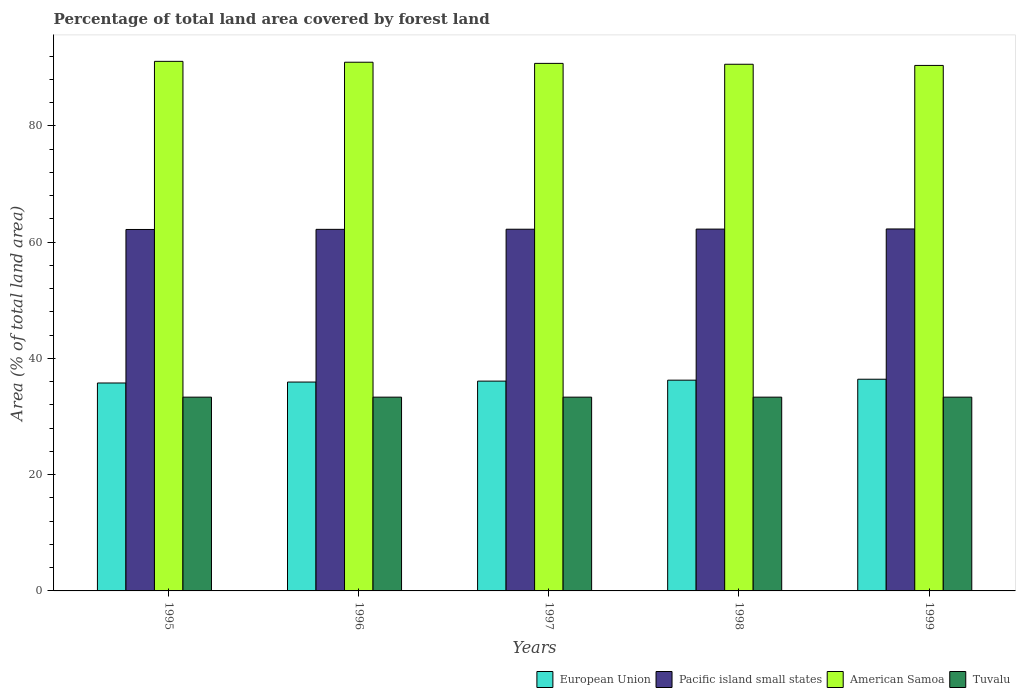How many different coloured bars are there?
Give a very brief answer. 4. How many groups of bars are there?
Make the answer very short. 5. Are the number of bars on each tick of the X-axis equal?
Offer a very short reply. Yes. How many bars are there on the 5th tick from the left?
Offer a very short reply. 4. In how many cases, is the number of bars for a given year not equal to the number of legend labels?
Your answer should be compact. 0. What is the percentage of forest land in Pacific island small states in 1999?
Make the answer very short. 62.27. Across all years, what is the maximum percentage of forest land in Tuvalu?
Offer a terse response. 33.33. Across all years, what is the minimum percentage of forest land in Tuvalu?
Ensure brevity in your answer.  33.33. In which year was the percentage of forest land in European Union maximum?
Offer a terse response. 1999. In which year was the percentage of forest land in Pacific island small states minimum?
Make the answer very short. 1995. What is the total percentage of forest land in Pacific island small states in the graph?
Offer a terse response. 311.11. What is the difference between the percentage of forest land in European Union in 1996 and that in 1999?
Keep it short and to the point. -0.49. What is the difference between the percentage of forest land in Pacific island small states in 1996 and the percentage of forest land in European Union in 1995?
Offer a very short reply. 26.43. What is the average percentage of forest land in American Samoa per year?
Provide a short and direct response. 90.76. In the year 1999, what is the difference between the percentage of forest land in American Samoa and percentage of forest land in Pacific island small states?
Give a very brief answer. 28.13. In how many years, is the percentage of forest land in European Union greater than 84 %?
Provide a succinct answer. 0. What is the ratio of the percentage of forest land in American Samoa in 1996 to that in 1999?
Keep it short and to the point. 1.01. Is the percentage of forest land in American Samoa in 1995 less than that in 1999?
Your answer should be very brief. No. What is the difference between the highest and the second highest percentage of forest land in Pacific island small states?
Provide a succinct answer. 0.02. What is the difference between the highest and the lowest percentage of forest land in European Union?
Offer a very short reply. 0.65. In how many years, is the percentage of forest land in European Union greater than the average percentage of forest land in European Union taken over all years?
Make the answer very short. 2. Is the sum of the percentage of forest land in Tuvalu in 1995 and 1999 greater than the maximum percentage of forest land in European Union across all years?
Make the answer very short. Yes. What does the 2nd bar from the left in 1997 represents?
Your response must be concise. Pacific island small states. What does the 3rd bar from the right in 1996 represents?
Your answer should be very brief. Pacific island small states. How many years are there in the graph?
Provide a succinct answer. 5. What is the difference between two consecutive major ticks on the Y-axis?
Your answer should be compact. 20. Are the values on the major ticks of Y-axis written in scientific E-notation?
Offer a terse response. No. Does the graph contain grids?
Your answer should be compact. No. Where does the legend appear in the graph?
Give a very brief answer. Bottom right. How are the legend labels stacked?
Keep it short and to the point. Horizontal. What is the title of the graph?
Give a very brief answer. Percentage of total land area covered by forest land. Does "United Kingdom" appear as one of the legend labels in the graph?
Offer a very short reply. No. What is the label or title of the Y-axis?
Your response must be concise. Area (% of total land area). What is the Area (% of total land area) in European Union in 1995?
Your response must be concise. 35.77. What is the Area (% of total land area) of Pacific island small states in 1995?
Your answer should be very brief. 62.18. What is the Area (% of total land area) in American Samoa in 1995?
Offer a very short reply. 91.1. What is the Area (% of total land area) of Tuvalu in 1995?
Offer a terse response. 33.33. What is the Area (% of total land area) in European Union in 1996?
Keep it short and to the point. 35.93. What is the Area (% of total land area) of Pacific island small states in 1996?
Make the answer very short. 62.2. What is the Area (% of total land area) in American Samoa in 1996?
Provide a short and direct response. 90.95. What is the Area (% of total land area) in Tuvalu in 1996?
Your answer should be compact. 33.33. What is the Area (% of total land area) in European Union in 1997?
Ensure brevity in your answer.  36.09. What is the Area (% of total land area) of Pacific island small states in 1997?
Your answer should be very brief. 62.22. What is the Area (% of total land area) in American Samoa in 1997?
Make the answer very short. 90.75. What is the Area (% of total land area) in Tuvalu in 1997?
Ensure brevity in your answer.  33.33. What is the Area (% of total land area) of European Union in 1998?
Your response must be concise. 36.26. What is the Area (% of total land area) of Pacific island small states in 1998?
Offer a terse response. 62.24. What is the Area (% of total land area) in American Samoa in 1998?
Give a very brief answer. 90.6. What is the Area (% of total land area) of Tuvalu in 1998?
Provide a short and direct response. 33.33. What is the Area (% of total land area) in European Union in 1999?
Ensure brevity in your answer.  36.42. What is the Area (% of total land area) of Pacific island small states in 1999?
Keep it short and to the point. 62.27. What is the Area (% of total land area) of American Samoa in 1999?
Your response must be concise. 90.4. What is the Area (% of total land area) in Tuvalu in 1999?
Give a very brief answer. 33.33. Across all years, what is the maximum Area (% of total land area) of European Union?
Offer a very short reply. 36.42. Across all years, what is the maximum Area (% of total land area) of Pacific island small states?
Keep it short and to the point. 62.27. Across all years, what is the maximum Area (% of total land area) of American Samoa?
Ensure brevity in your answer.  91.1. Across all years, what is the maximum Area (% of total land area) of Tuvalu?
Your answer should be very brief. 33.33. Across all years, what is the minimum Area (% of total land area) of European Union?
Your answer should be very brief. 35.77. Across all years, what is the minimum Area (% of total land area) in Pacific island small states?
Your response must be concise. 62.18. Across all years, what is the minimum Area (% of total land area) of American Samoa?
Make the answer very short. 90.4. Across all years, what is the minimum Area (% of total land area) in Tuvalu?
Your answer should be very brief. 33.33. What is the total Area (% of total land area) in European Union in the graph?
Provide a short and direct response. 180.46. What is the total Area (% of total land area) of Pacific island small states in the graph?
Make the answer very short. 311.11. What is the total Area (% of total land area) of American Samoa in the graph?
Provide a short and direct response. 453.8. What is the total Area (% of total land area) in Tuvalu in the graph?
Make the answer very short. 166.67. What is the difference between the Area (% of total land area) of European Union in 1995 and that in 1996?
Your answer should be very brief. -0.16. What is the difference between the Area (% of total land area) in Pacific island small states in 1995 and that in 1996?
Give a very brief answer. -0.02. What is the difference between the Area (% of total land area) in American Samoa in 1995 and that in 1996?
Make the answer very short. 0.15. What is the difference between the Area (% of total land area) in Tuvalu in 1995 and that in 1996?
Provide a succinct answer. 0. What is the difference between the Area (% of total land area) in European Union in 1995 and that in 1997?
Your answer should be compact. -0.32. What is the difference between the Area (% of total land area) of Pacific island small states in 1995 and that in 1997?
Offer a terse response. -0.04. What is the difference between the Area (% of total land area) of American Samoa in 1995 and that in 1997?
Give a very brief answer. 0.35. What is the difference between the Area (% of total land area) in Tuvalu in 1995 and that in 1997?
Offer a very short reply. 0. What is the difference between the Area (% of total land area) of European Union in 1995 and that in 1998?
Give a very brief answer. -0.49. What is the difference between the Area (% of total land area) in Pacific island small states in 1995 and that in 1998?
Provide a succinct answer. -0.07. What is the difference between the Area (% of total land area) of Tuvalu in 1995 and that in 1998?
Give a very brief answer. 0. What is the difference between the Area (% of total land area) in European Union in 1995 and that in 1999?
Your answer should be compact. -0.65. What is the difference between the Area (% of total land area) in Pacific island small states in 1995 and that in 1999?
Ensure brevity in your answer.  -0.09. What is the difference between the Area (% of total land area) in Tuvalu in 1995 and that in 1999?
Offer a terse response. 0. What is the difference between the Area (% of total land area) in European Union in 1996 and that in 1997?
Ensure brevity in your answer.  -0.16. What is the difference between the Area (% of total land area) of Pacific island small states in 1996 and that in 1997?
Offer a very short reply. -0.02. What is the difference between the Area (% of total land area) of American Samoa in 1996 and that in 1997?
Keep it short and to the point. 0.2. What is the difference between the Area (% of total land area) in Tuvalu in 1996 and that in 1997?
Your answer should be compact. 0. What is the difference between the Area (% of total land area) of European Union in 1996 and that in 1998?
Provide a succinct answer. -0.32. What is the difference between the Area (% of total land area) of Pacific island small states in 1996 and that in 1998?
Make the answer very short. -0.04. What is the difference between the Area (% of total land area) in Tuvalu in 1996 and that in 1998?
Make the answer very short. 0. What is the difference between the Area (% of total land area) of European Union in 1996 and that in 1999?
Your answer should be compact. -0.49. What is the difference between the Area (% of total land area) in Pacific island small states in 1996 and that in 1999?
Provide a succinct answer. -0.07. What is the difference between the Area (% of total land area) of American Samoa in 1996 and that in 1999?
Your answer should be very brief. 0.55. What is the difference between the Area (% of total land area) of European Union in 1997 and that in 1998?
Offer a very short reply. -0.16. What is the difference between the Area (% of total land area) of Pacific island small states in 1997 and that in 1998?
Your answer should be very brief. -0.02. What is the difference between the Area (% of total land area) in European Union in 1997 and that in 1999?
Ensure brevity in your answer.  -0.32. What is the difference between the Area (% of total land area) in Pacific island small states in 1997 and that in 1999?
Offer a terse response. -0.04. What is the difference between the Area (% of total land area) of European Union in 1998 and that in 1999?
Give a very brief answer. -0.16. What is the difference between the Area (% of total land area) in Pacific island small states in 1998 and that in 1999?
Your response must be concise. -0.02. What is the difference between the Area (% of total land area) in Tuvalu in 1998 and that in 1999?
Provide a succinct answer. 0. What is the difference between the Area (% of total land area) in European Union in 1995 and the Area (% of total land area) in Pacific island small states in 1996?
Offer a very short reply. -26.43. What is the difference between the Area (% of total land area) of European Union in 1995 and the Area (% of total land area) of American Samoa in 1996?
Your answer should be compact. -55.18. What is the difference between the Area (% of total land area) in European Union in 1995 and the Area (% of total land area) in Tuvalu in 1996?
Ensure brevity in your answer.  2.44. What is the difference between the Area (% of total land area) of Pacific island small states in 1995 and the Area (% of total land area) of American Samoa in 1996?
Give a very brief answer. -28.77. What is the difference between the Area (% of total land area) of Pacific island small states in 1995 and the Area (% of total land area) of Tuvalu in 1996?
Provide a succinct answer. 28.84. What is the difference between the Area (% of total land area) in American Samoa in 1995 and the Area (% of total land area) in Tuvalu in 1996?
Give a very brief answer. 57.77. What is the difference between the Area (% of total land area) in European Union in 1995 and the Area (% of total land area) in Pacific island small states in 1997?
Make the answer very short. -26.45. What is the difference between the Area (% of total land area) of European Union in 1995 and the Area (% of total land area) of American Samoa in 1997?
Your response must be concise. -54.98. What is the difference between the Area (% of total land area) of European Union in 1995 and the Area (% of total land area) of Tuvalu in 1997?
Your response must be concise. 2.44. What is the difference between the Area (% of total land area) in Pacific island small states in 1995 and the Area (% of total land area) in American Samoa in 1997?
Offer a very short reply. -28.57. What is the difference between the Area (% of total land area) in Pacific island small states in 1995 and the Area (% of total land area) in Tuvalu in 1997?
Your answer should be compact. 28.84. What is the difference between the Area (% of total land area) in American Samoa in 1995 and the Area (% of total land area) in Tuvalu in 1997?
Ensure brevity in your answer.  57.77. What is the difference between the Area (% of total land area) in European Union in 1995 and the Area (% of total land area) in Pacific island small states in 1998?
Offer a very short reply. -26.47. What is the difference between the Area (% of total land area) of European Union in 1995 and the Area (% of total land area) of American Samoa in 1998?
Your answer should be very brief. -54.83. What is the difference between the Area (% of total land area) of European Union in 1995 and the Area (% of total land area) of Tuvalu in 1998?
Your response must be concise. 2.44. What is the difference between the Area (% of total land area) in Pacific island small states in 1995 and the Area (% of total land area) in American Samoa in 1998?
Your response must be concise. -28.42. What is the difference between the Area (% of total land area) in Pacific island small states in 1995 and the Area (% of total land area) in Tuvalu in 1998?
Provide a succinct answer. 28.84. What is the difference between the Area (% of total land area) in American Samoa in 1995 and the Area (% of total land area) in Tuvalu in 1998?
Provide a short and direct response. 57.77. What is the difference between the Area (% of total land area) of European Union in 1995 and the Area (% of total land area) of Pacific island small states in 1999?
Make the answer very short. -26.5. What is the difference between the Area (% of total land area) in European Union in 1995 and the Area (% of total land area) in American Samoa in 1999?
Provide a succinct answer. -54.63. What is the difference between the Area (% of total land area) in European Union in 1995 and the Area (% of total land area) in Tuvalu in 1999?
Provide a succinct answer. 2.44. What is the difference between the Area (% of total land area) of Pacific island small states in 1995 and the Area (% of total land area) of American Samoa in 1999?
Make the answer very short. -28.22. What is the difference between the Area (% of total land area) in Pacific island small states in 1995 and the Area (% of total land area) in Tuvalu in 1999?
Provide a short and direct response. 28.84. What is the difference between the Area (% of total land area) of American Samoa in 1995 and the Area (% of total land area) of Tuvalu in 1999?
Make the answer very short. 57.77. What is the difference between the Area (% of total land area) in European Union in 1996 and the Area (% of total land area) in Pacific island small states in 1997?
Ensure brevity in your answer.  -26.29. What is the difference between the Area (% of total land area) of European Union in 1996 and the Area (% of total land area) of American Samoa in 1997?
Keep it short and to the point. -54.82. What is the difference between the Area (% of total land area) in European Union in 1996 and the Area (% of total land area) in Tuvalu in 1997?
Offer a very short reply. 2.6. What is the difference between the Area (% of total land area) of Pacific island small states in 1996 and the Area (% of total land area) of American Samoa in 1997?
Your response must be concise. -28.55. What is the difference between the Area (% of total land area) in Pacific island small states in 1996 and the Area (% of total land area) in Tuvalu in 1997?
Offer a very short reply. 28.87. What is the difference between the Area (% of total land area) in American Samoa in 1996 and the Area (% of total land area) in Tuvalu in 1997?
Keep it short and to the point. 57.62. What is the difference between the Area (% of total land area) in European Union in 1996 and the Area (% of total land area) in Pacific island small states in 1998?
Ensure brevity in your answer.  -26.31. What is the difference between the Area (% of total land area) of European Union in 1996 and the Area (% of total land area) of American Samoa in 1998?
Keep it short and to the point. -54.67. What is the difference between the Area (% of total land area) in European Union in 1996 and the Area (% of total land area) in Tuvalu in 1998?
Ensure brevity in your answer.  2.6. What is the difference between the Area (% of total land area) of Pacific island small states in 1996 and the Area (% of total land area) of American Samoa in 1998?
Your response must be concise. -28.4. What is the difference between the Area (% of total land area) in Pacific island small states in 1996 and the Area (% of total land area) in Tuvalu in 1998?
Offer a terse response. 28.87. What is the difference between the Area (% of total land area) of American Samoa in 1996 and the Area (% of total land area) of Tuvalu in 1998?
Your answer should be very brief. 57.62. What is the difference between the Area (% of total land area) of European Union in 1996 and the Area (% of total land area) of Pacific island small states in 1999?
Keep it short and to the point. -26.34. What is the difference between the Area (% of total land area) of European Union in 1996 and the Area (% of total land area) of American Samoa in 1999?
Your answer should be very brief. -54.47. What is the difference between the Area (% of total land area) of European Union in 1996 and the Area (% of total land area) of Tuvalu in 1999?
Ensure brevity in your answer.  2.6. What is the difference between the Area (% of total land area) of Pacific island small states in 1996 and the Area (% of total land area) of American Samoa in 1999?
Give a very brief answer. -28.2. What is the difference between the Area (% of total land area) in Pacific island small states in 1996 and the Area (% of total land area) in Tuvalu in 1999?
Keep it short and to the point. 28.87. What is the difference between the Area (% of total land area) of American Samoa in 1996 and the Area (% of total land area) of Tuvalu in 1999?
Give a very brief answer. 57.62. What is the difference between the Area (% of total land area) in European Union in 1997 and the Area (% of total land area) in Pacific island small states in 1998?
Provide a succinct answer. -26.15. What is the difference between the Area (% of total land area) of European Union in 1997 and the Area (% of total land area) of American Samoa in 1998?
Your answer should be very brief. -54.51. What is the difference between the Area (% of total land area) of European Union in 1997 and the Area (% of total land area) of Tuvalu in 1998?
Your answer should be very brief. 2.76. What is the difference between the Area (% of total land area) in Pacific island small states in 1997 and the Area (% of total land area) in American Samoa in 1998?
Your answer should be compact. -28.38. What is the difference between the Area (% of total land area) in Pacific island small states in 1997 and the Area (% of total land area) in Tuvalu in 1998?
Your response must be concise. 28.89. What is the difference between the Area (% of total land area) of American Samoa in 1997 and the Area (% of total land area) of Tuvalu in 1998?
Make the answer very short. 57.42. What is the difference between the Area (% of total land area) of European Union in 1997 and the Area (% of total land area) of Pacific island small states in 1999?
Give a very brief answer. -26.17. What is the difference between the Area (% of total land area) of European Union in 1997 and the Area (% of total land area) of American Samoa in 1999?
Offer a terse response. -54.31. What is the difference between the Area (% of total land area) in European Union in 1997 and the Area (% of total land area) in Tuvalu in 1999?
Offer a very short reply. 2.76. What is the difference between the Area (% of total land area) in Pacific island small states in 1997 and the Area (% of total land area) in American Samoa in 1999?
Make the answer very short. -28.18. What is the difference between the Area (% of total land area) of Pacific island small states in 1997 and the Area (% of total land area) of Tuvalu in 1999?
Give a very brief answer. 28.89. What is the difference between the Area (% of total land area) in American Samoa in 1997 and the Area (% of total land area) in Tuvalu in 1999?
Your answer should be very brief. 57.42. What is the difference between the Area (% of total land area) in European Union in 1998 and the Area (% of total land area) in Pacific island small states in 1999?
Offer a terse response. -26.01. What is the difference between the Area (% of total land area) of European Union in 1998 and the Area (% of total land area) of American Samoa in 1999?
Give a very brief answer. -54.14. What is the difference between the Area (% of total land area) in European Union in 1998 and the Area (% of total land area) in Tuvalu in 1999?
Offer a terse response. 2.92. What is the difference between the Area (% of total land area) of Pacific island small states in 1998 and the Area (% of total land area) of American Samoa in 1999?
Your answer should be very brief. -28.16. What is the difference between the Area (% of total land area) in Pacific island small states in 1998 and the Area (% of total land area) in Tuvalu in 1999?
Your answer should be compact. 28.91. What is the difference between the Area (% of total land area) of American Samoa in 1998 and the Area (% of total land area) of Tuvalu in 1999?
Give a very brief answer. 57.27. What is the average Area (% of total land area) in European Union per year?
Make the answer very short. 36.09. What is the average Area (% of total land area) of Pacific island small states per year?
Offer a very short reply. 62.22. What is the average Area (% of total land area) in American Samoa per year?
Provide a short and direct response. 90.76. What is the average Area (% of total land area) of Tuvalu per year?
Provide a short and direct response. 33.33. In the year 1995, what is the difference between the Area (% of total land area) of European Union and Area (% of total land area) of Pacific island small states?
Provide a succinct answer. -26.41. In the year 1995, what is the difference between the Area (% of total land area) in European Union and Area (% of total land area) in American Samoa?
Ensure brevity in your answer.  -55.33. In the year 1995, what is the difference between the Area (% of total land area) of European Union and Area (% of total land area) of Tuvalu?
Give a very brief answer. 2.44. In the year 1995, what is the difference between the Area (% of total land area) of Pacific island small states and Area (% of total land area) of American Samoa?
Provide a short and direct response. -28.92. In the year 1995, what is the difference between the Area (% of total land area) in Pacific island small states and Area (% of total land area) in Tuvalu?
Your answer should be compact. 28.84. In the year 1995, what is the difference between the Area (% of total land area) of American Samoa and Area (% of total land area) of Tuvalu?
Provide a succinct answer. 57.77. In the year 1996, what is the difference between the Area (% of total land area) of European Union and Area (% of total land area) of Pacific island small states?
Make the answer very short. -26.27. In the year 1996, what is the difference between the Area (% of total land area) in European Union and Area (% of total land area) in American Samoa?
Keep it short and to the point. -55.02. In the year 1996, what is the difference between the Area (% of total land area) of European Union and Area (% of total land area) of Tuvalu?
Keep it short and to the point. 2.6. In the year 1996, what is the difference between the Area (% of total land area) of Pacific island small states and Area (% of total land area) of American Samoa?
Your answer should be very brief. -28.75. In the year 1996, what is the difference between the Area (% of total land area) in Pacific island small states and Area (% of total land area) in Tuvalu?
Offer a very short reply. 28.87. In the year 1996, what is the difference between the Area (% of total land area) of American Samoa and Area (% of total land area) of Tuvalu?
Give a very brief answer. 57.62. In the year 1997, what is the difference between the Area (% of total land area) in European Union and Area (% of total land area) in Pacific island small states?
Provide a short and direct response. -26.13. In the year 1997, what is the difference between the Area (% of total land area) of European Union and Area (% of total land area) of American Samoa?
Give a very brief answer. -54.66. In the year 1997, what is the difference between the Area (% of total land area) in European Union and Area (% of total land area) in Tuvalu?
Provide a short and direct response. 2.76. In the year 1997, what is the difference between the Area (% of total land area) of Pacific island small states and Area (% of total land area) of American Samoa?
Give a very brief answer. -28.53. In the year 1997, what is the difference between the Area (% of total land area) of Pacific island small states and Area (% of total land area) of Tuvalu?
Provide a short and direct response. 28.89. In the year 1997, what is the difference between the Area (% of total land area) of American Samoa and Area (% of total land area) of Tuvalu?
Your answer should be compact. 57.42. In the year 1998, what is the difference between the Area (% of total land area) of European Union and Area (% of total land area) of Pacific island small states?
Offer a terse response. -25.99. In the year 1998, what is the difference between the Area (% of total land area) of European Union and Area (% of total land area) of American Samoa?
Your answer should be compact. -54.34. In the year 1998, what is the difference between the Area (% of total land area) of European Union and Area (% of total land area) of Tuvalu?
Give a very brief answer. 2.92. In the year 1998, what is the difference between the Area (% of total land area) of Pacific island small states and Area (% of total land area) of American Samoa?
Your answer should be very brief. -28.36. In the year 1998, what is the difference between the Area (% of total land area) of Pacific island small states and Area (% of total land area) of Tuvalu?
Your answer should be very brief. 28.91. In the year 1998, what is the difference between the Area (% of total land area) in American Samoa and Area (% of total land area) in Tuvalu?
Make the answer very short. 57.27. In the year 1999, what is the difference between the Area (% of total land area) of European Union and Area (% of total land area) of Pacific island small states?
Your response must be concise. -25.85. In the year 1999, what is the difference between the Area (% of total land area) in European Union and Area (% of total land area) in American Samoa?
Offer a terse response. -53.98. In the year 1999, what is the difference between the Area (% of total land area) of European Union and Area (% of total land area) of Tuvalu?
Your answer should be very brief. 3.08. In the year 1999, what is the difference between the Area (% of total land area) of Pacific island small states and Area (% of total land area) of American Samoa?
Your answer should be compact. -28.13. In the year 1999, what is the difference between the Area (% of total land area) in Pacific island small states and Area (% of total land area) in Tuvalu?
Your response must be concise. 28.93. In the year 1999, what is the difference between the Area (% of total land area) in American Samoa and Area (% of total land area) in Tuvalu?
Make the answer very short. 57.07. What is the ratio of the Area (% of total land area) in Pacific island small states in 1995 to that in 1996?
Offer a terse response. 1. What is the ratio of the Area (% of total land area) in European Union in 1995 to that in 1997?
Ensure brevity in your answer.  0.99. What is the ratio of the Area (% of total land area) of Tuvalu in 1995 to that in 1997?
Your response must be concise. 1. What is the ratio of the Area (% of total land area) of European Union in 1995 to that in 1998?
Keep it short and to the point. 0.99. What is the ratio of the Area (% of total land area) in Pacific island small states in 1995 to that in 1998?
Provide a short and direct response. 1. What is the ratio of the Area (% of total land area) of European Union in 1995 to that in 1999?
Make the answer very short. 0.98. What is the ratio of the Area (% of total land area) of American Samoa in 1995 to that in 1999?
Keep it short and to the point. 1.01. What is the ratio of the Area (% of total land area) of American Samoa in 1996 to that in 1997?
Give a very brief answer. 1. What is the ratio of the Area (% of total land area) of Pacific island small states in 1996 to that in 1998?
Your answer should be very brief. 1. What is the ratio of the Area (% of total land area) of Tuvalu in 1996 to that in 1998?
Make the answer very short. 1. What is the ratio of the Area (% of total land area) of European Union in 1996 to that in 1999?
Your response must be concise. 0.99. What is the ratio of the Area (% of total land area) of European Union in 1997 to that in 1998?
Make the answer very short. 1. What is the ratio of the Area (% of total land area) of Pacific island small states in 1997 to that in 1998?
Provide a succinct answer. 1. What is the ratio of the Area (% of total land area) in American Samoa in 1997 to that in 1998?
Your answer should be very brief. 1. What is the ratio of the Area (% of total land area) in Tuvalu in 1997 to that in 1998?
Your response must be concise. 1. What is the ratio of the Area (% of total land area) in American Samoa in 1997 to that in 1999?
Ensure brevity in your answer.  1. What is the ratio of the Area (% of total land area) of Tuvalu in 1997 to that in 1999?
Ensure brevity in your answer.  1. What is the ratio of the Area (% of total land area) of Pacific island small states in 1998 to that in 1999?
Provide a short and direct response. 1. What is the ratio of the Area (% of total land area) in American Samoa in 1998 to that in 1999?
Offer a very short reply. 1. What is the ratio of the Area (% of total land area) in Tuvalu in 1998 to that in 1999?
Offer a very short reply. 1. What is the difference between the highest and the second highest Area (% of total land area) of European Union?
Offer a very short reply. 0.16. What is the difference between the highest and the second highest Area (% of total land area) in Pacific island small states?
Provide a succinct answer. 0.02. What is the difference between the highest and the second highest Area (% of total land area) of American Samoa?
Your answer should be very brief. 0.15. What is the difference between the highest and the lowest Area (% of total land area) of European Union?
Offer a very short reply. 0.65. What is the difference between the highest and the lowest Area (% of total land area) of Pacific island small states?
Your answer should be compact. 0.09. What is the difference between the highest and the lowest Area (% of total land area) in American Samoa?
Offer a terse response. 0.7. What is the difference between the highest and the lowest Area (% of total land area) in Tuvalu?
Provide a short and direct response. 0. 